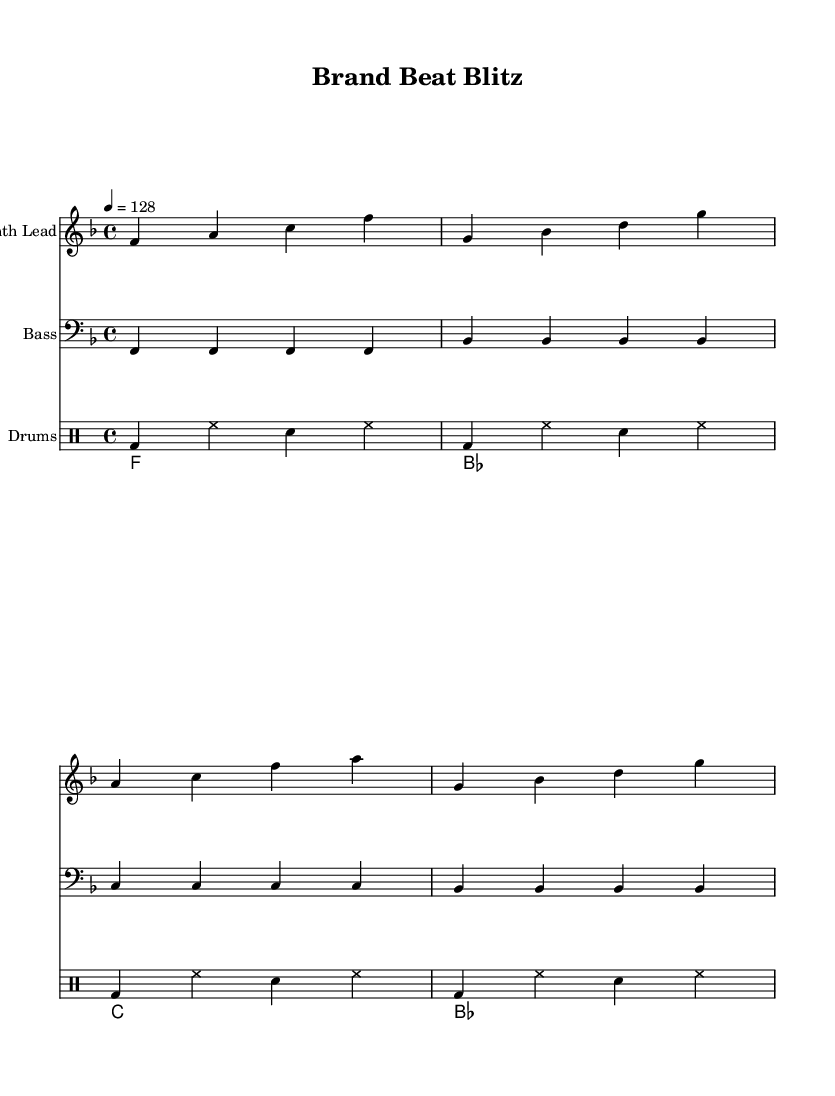What is the time signature of this music? The time signature is indicated at the beginning of the score, showing that there are four beats in each measure. This is represented as 4/4.
Answer: 4/4 What is the key signature of this music? The key signature is found at the beginning of the score, representing F major, which contains one flat (B flat).
Answer: F major What is the tempo marking of this piece? The tempo is specified above the music and indicates the speed at which the piece should be played, given as a quarter note equals 128 beats per minute.
Answer: 128 How many measures are there in the synth lead section? By counting the distinct groups of notes in the synth lead part, we see there are four measures listed.
Answer: 4 What is the primary function of the bass line? The bass line in this house music serves to provide the harmonic foundation, primarily repeating a simple rhythmic pattern that complements the synth lead.
Answer: Harmonic foundation What thematic element is emphasized in the lyrics? The lyrics focus on themes of branding and innovation, capturing a motivational and aspirational message that's often needed in marketing contexts.
Answer: Branding and innovation Which type of musical instrument is represented by the third staff? This staff represents a percussive section, which is designated for drums, providing rhythm and beat.
Answer: Drums 